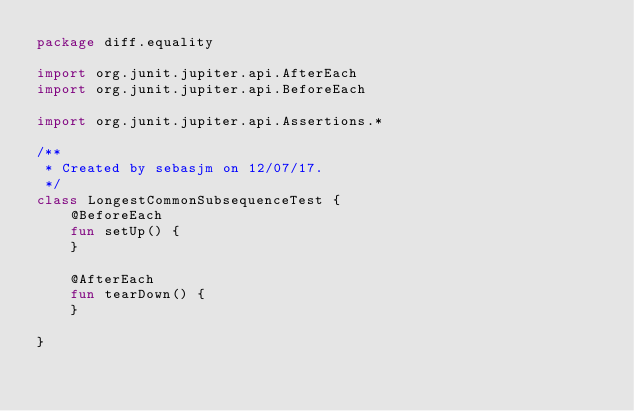Convert code to text. <code><loc_0><loc_0><loc_500><loc_500><_Kotlin_>package diff.equality

import org.junit.jupiter.api.AfterEach
import org.junit.jupiter.api.BeforeEach

import org.junit.jupiter.api.Assertions.*

/**
 * Created by sebasjm on 12/07/17.
 */
class LongestCommonSubsequenceTest {
    @BeforeEach
    fun setUp() {
    }

    @AfterEach
    fun tearDown() {
    }

}</code> 